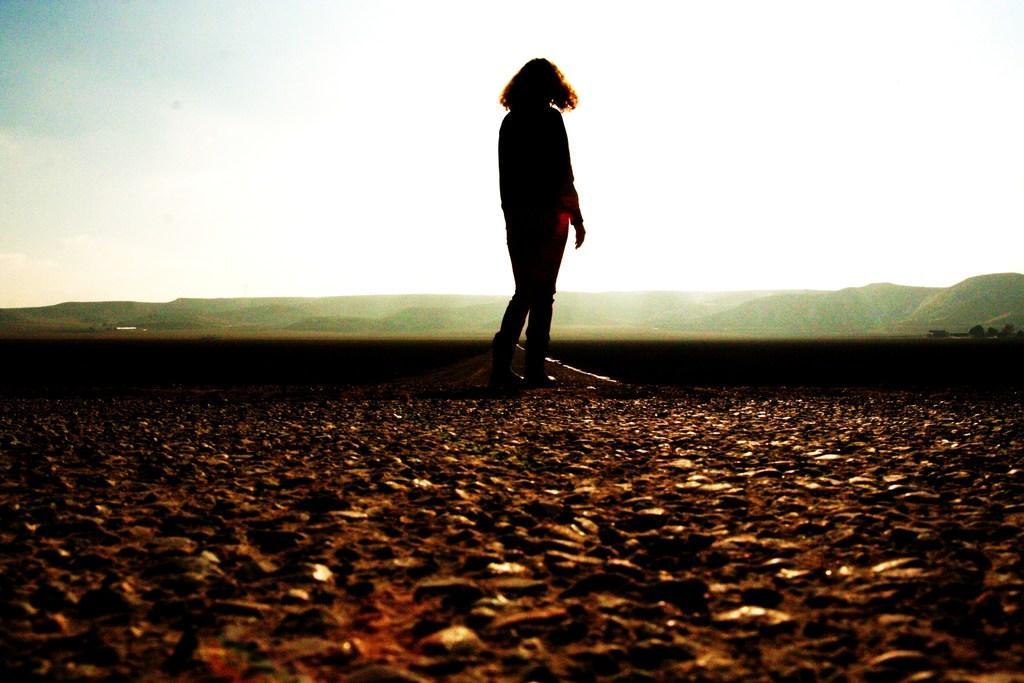How would you summarize this image in a sentence or two? In this image in the center there is one person who is standing, and at the bottom there is sand. In the background there are some mountains, and at the top of the image there is sky. 